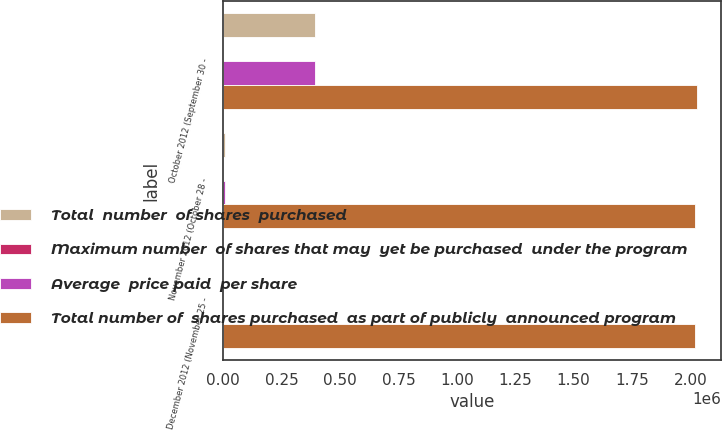Convert chart to OTSL. <chart><loc_0><loc_0><loc_500><loc_500><stacked_bar_chart><ecel><fcel>October 2012 (September 30 -<fcel>November 2012 (October 28 -<fcel>December 2012 (November 25 -<nl><fcel>Total  number  of shares  purchased<fcel>392146<fcel>7854<fcel>0<nl><fcel>Maximum number  of shares that may  yet be purchased  under the program<fcel>36.71<fcel>35.67<fcel>0<nl><fcel>Average  price paid  per share<fcel>392146<fcel>7854<fcel>0<nl><fcel>Total number of  shares purchased  as part of publicly  announced program<fcel>2.03019e+06<fcel>2.02234e+06<fcel>2.02234e+06<nl></chart> 